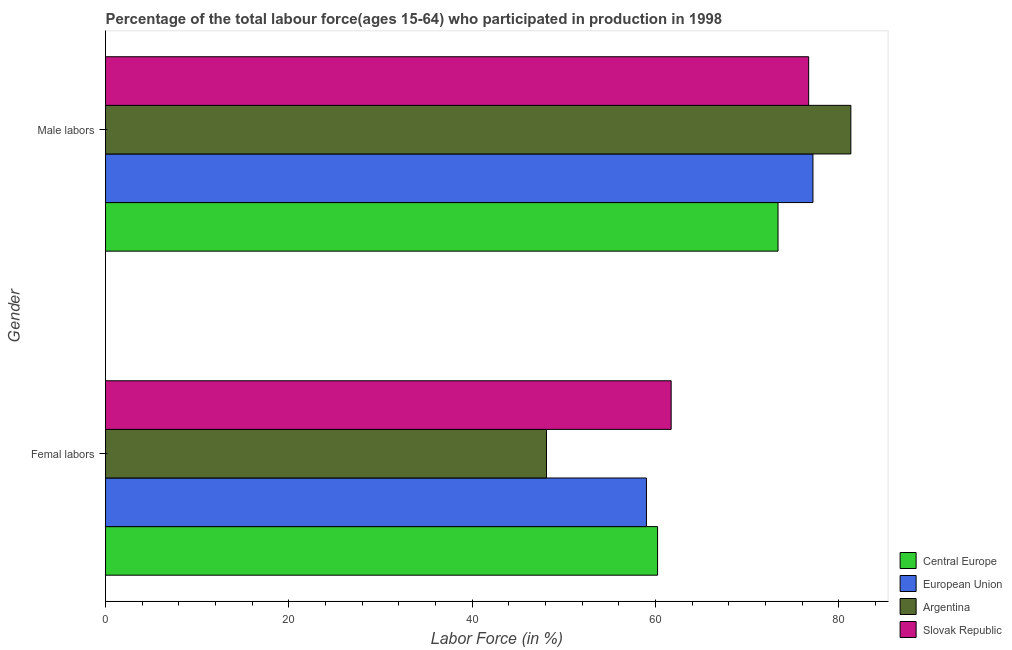How many groups of bars are there?
Keep it short and to the point. 2. How many bars are there on the 2nd tick from the bottom?
Your response must be concise. 4. What is the label of the 2nd group of bars from the top?
Give a very brief answer. Femal labors. What is the percentage of male labour force in Central Europe?
Your answer should be compact. 73.36. Across all countries, what is the maximum percentage of male labour force?
Your response must be concise. 81.3. Across all countries, what is the minimum percentage of male labour force?
Provide a short and direct response. 73.36. In which country was the percentage of female labor force maximum?
Provide a succinct answer. Slovak Republic. In which country was the percentage of male labour force minimum?
Make the answer very short. Central Europe. What is the total percentage of female labor force in the graph?
Ensure brevity in your answer.  229.02. What is the difference between the percentage of female labor force in Central Europe and that in European Union?
Keep it short and to the point. 1.22. What is the difference between the percentage of male labour force in Central Europe and the percentage of female labor force in Slovak Republic?
Provide a short and direct response. 11.66. What is the average percentage of male labour force per country?
Your response must be concise. 77.13. What is the difference between the percentage of male labour force and percentage of female labor force in Central Europe?
Your answer should be very brief. 13.14. What is the ratio of the percentage of male labour force in Slovak Republic to that in Central Europe?
Your answer should be very brief. 1.05. Is the percentage of female labor force in Argentina less than that in Slovak Republic?
Give a very brief answer. Yes. What does the 3rd bar from the top in Male labors represents?
Your answer should be compact. European Union. What does the 2nd bar from the bottom in Femal labors represents?
Provide a succinct answer. European Union. How many countries are there in the graph?
Provide a succinct answer. 4. Are the values on the major ticks of X-axis written in scientific E-notation?
Offer a terse response. No. Where does the legend appear in the graph?
Provide a short and direct response. Bottom right. How many legend labels are there?
Offer a very short reply. 4. What is the title of the graph?
Your answer should be compact. Percentage of the total labour force(ages 15-64) who participated in production in 1998. Does "Turks and Caicos Islands" appear as one of the legend labels in the graph?
Keep it short and to the point. No. What is the Labor Force (in %) of Central Europe in Femal labors?
Your answer should be compact. 60.22. What is the Labor Force (in %) of European Union in Femal labors?
Offer a terse response. 59. What is the Labor Force (in %) in Argentina in Femal labors?
Provide a succinct answer. 48.1. What is the Labor Force (in %) in Slovak Republic in Femal labors?
Make the answer very short. 61.7. What is the Labor Force (in %) in Central Europe in Male labors?
Offer a very short reply. 73.36. What is the Labor Force (in %) in European Union in Male labors?
Offer a terse response. 77.17. What is the Labor Force (in %) in Argentina in Male labors?
Offer a terse response. 81.3. What is the Labor Force (in %) of Slovak Republic in Male labors?
Make the answer very short. 76.7. Across all Gender, what is the maximum Labor Force (in %) of Central Europe?
Your answer should be very brief. 73.36. Across all Gender, what is the maximum Labor Force (in %) in European Union?
Provide a short and direct response. 77.17. Across all Gender, what is the maximum Labor Force (in %) of Argentina?
Ensure brevity in your answer.  81.3. Across all Gender, what is the maximum Labor Force (in %) of Slovak Republic?
Make the answer very short. 76.7. Across all Gender, what is the minimum Labor Force (in %) of Central Europe?
Offer a very short reply. 60.22. Across all Gender, what is the minimum Labor Force (in %) in European Union?
Make the answer very short. 59. Across all Gender, what is the minimum Labor Force (in %) of Argentina?
Make the answer very short. 48.1. Across all Gender, what is the minimum Labor Force (in %) in Slovak Republic?
Your answer should be compact. 61.7. What is the total Labor Force (in %) of Central Europe in the graph?
Your answer should be compact. 133.58. What is the total Labor Force (in %) in European Union in the graph?
Provide a short and direct response. 136.17. What is the total Labor Force (in %) in Argentina in the graph?
Your answer should be compact. 129.4. What is the total Labor Force (in %) of Slovak Republic in the graph?
Provide a succinct answer. 138.4. What is the difference between the Labor Force (in %) in Central Europe in Femal labors and that in Male labors?
Ensure brevity in your answer.  -13.14. What is the difference between the Labor Force (in %) in European Union in Femal labors and that in Male labors?
Your answer should be compact. -18.16. What is the difference between the Labor Force (in %) of Argentina in Femal labors and that in Male labors?
Ensure brevity in your answer.  -33.2. What is the difference between the Labor Force (in %) in Central Europe in Femal labors and the Labor Force (in %) in European Union in Male labors?
Offer a very short reply. -16.95. What is the difference between the Labor Force (in %) in Central Europe in Femal labors and the Labor Force (in %) in Argentina in Male labors?
Keep it short and to the point. -21.08. What is the difference between the Labor Force (in %) of Central Europe in Femal labors and the Labor Force (in %) of Slovak Republic in Male labors?
Offer a very short reply. -16.48. What is the difference between the Labor Force (in %) in European Union in Femal labors and the Labor Force (in %) in Argentina in Male labors?
Your response must be concise. -22.3. What is the difference between the Labor Force (in %) of European Union in Femal labors and the Labor Force (in %) of Slovak Republic in Male labors?
Your answer should be compact. -17.7. What is the difference between the Labor Force (in %) of Argentina in Femal labors and the Labor Force (in %) of Slovak Republic in Male labors?
Ensure brevity in your answer.  -28.6. What is the average Labor Force (in %) in Central Europe per Gender?
Keep it short and to the point. 66.79. What is the average Labor Force (in %) in European Union per Gender?
Your response must be concise. 68.08. What is the average Labor Force (in %) of Argentina per Gender?
Your response must be concise. 64.7. What is the average Labor Force (in %) of Slovak Republic per Gender?
Your response must be concise. 69.2. What is the difference between the Labor Force (in %) in Central Europe and Labor Force (in %) in European Union in Femal labors?
Provide a succinct answer. 1.22. What is the difference between the Labor Force (in %) of Central Europe and Labor Force (in %) of Argentina in Femal labors?
Keep it short and to the point. 12.12. What is the difference between the Labor Force (in %) of Central Europe and Labor Force (in %) of Slovak Republic in Femal labors?
Your answer should be compact. -1.48. What is the difference between the Labor Force (in %) of European Union and Labor Force (in %) of Argentina in Femal labors?
Offer a very short reply. 10.9. What is the difference between the Labor Force (in %) of European Union and Labor Force (in %) of Slovak Republic in Femal labors?
Your response must be concise. -2.7. What is the difference between the Labor Force (in %) in Central Europe and Labor Force (in %) in European Union in Male labors?
Ensure brevity in your answer.  -3.81. What is the difference between the Labor Force (in %) in Central Europe and Labor Force (in %) in Argentina in Male labors?
Offer a very short reply. -7.94. What is the difference between the Labor Force (in %) in Central Europe and Labor Force (in %) in Slovak Republic in Male labors?
Offer a terse response. -3.34. What is the difference between the Labor Force (in %) in European Union and Labor Force (in %) in Argentina in Male labors?
Your answer should be very brief. -4.13. What is the difference between the Labor Force (in %) in European Union and Labor Force (in %) in Slovak Republic in Male labors?
Your answer should be compact. 0.47. What is the ratio of the Labor Force (in %) of Central Europe in Femal labors to that in Male labors?
Keep it short and to the point. 0.82. What is the ratio of the Labor Force (in %) of European Union in Femal labors to that in Male labors?
Offer a terse response. 0.76. What is the ratio of the Labor Force (in %) of Argentina in Femal labors to that in Male labors?
Your response must be concise. 0.59. What is the ratio of the Labor Force (in %) in Slovak Republic in Femal labors to that in Male labors?
Provide a succinct answer. 0.8. What is the difference between the highest and the second highest Labor Force (in %) of Central Europe?
Your answer should be compact. 13.14. What is the difference between the highest and the second highest Labor Force (in %) in European Union?
Your response must be concise. 18.16. What is the difference between the highest and the second highest Labor Force (in %) in Argentina?
Your response must be concise. 33.2. What is the difference between the highest and the lowest Labor Force (in %) of Central Europe?
Provide a succinct answer. 13.14. What is the difference between the highest and the lowest Labor Force (in %) of European Union?
Make the answer very short. 18.16. What is the difference between the highest and the lowest Labor Force (in %) in Argentina?
Your answer should be very brief. 33.2. What is the difference between the highest and the lowest Labor Force (in %) in Slovak Republic?
Offer a terse response. 15. 